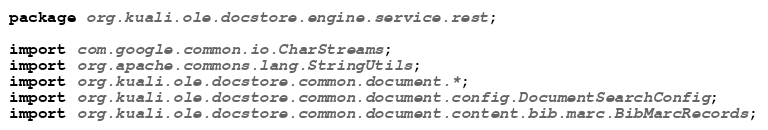Convert code to text. <code><loc_0><loc_0><loc_500><loc_500><_Java_>package org.kuali.ole.docstore.engine.service.rest;

import com.google.common.io.CharStreams;
import org.apache.commons.lang.StringUtils;
import org.kuali.ole.docstore.common.document.*;
import org.kuali.ole.docstore.common.document.config.DocumentSearchConfig;
import org.kuali.ole.docstore.common.document.content.bib.marc.BibMarcRecords;</code> 